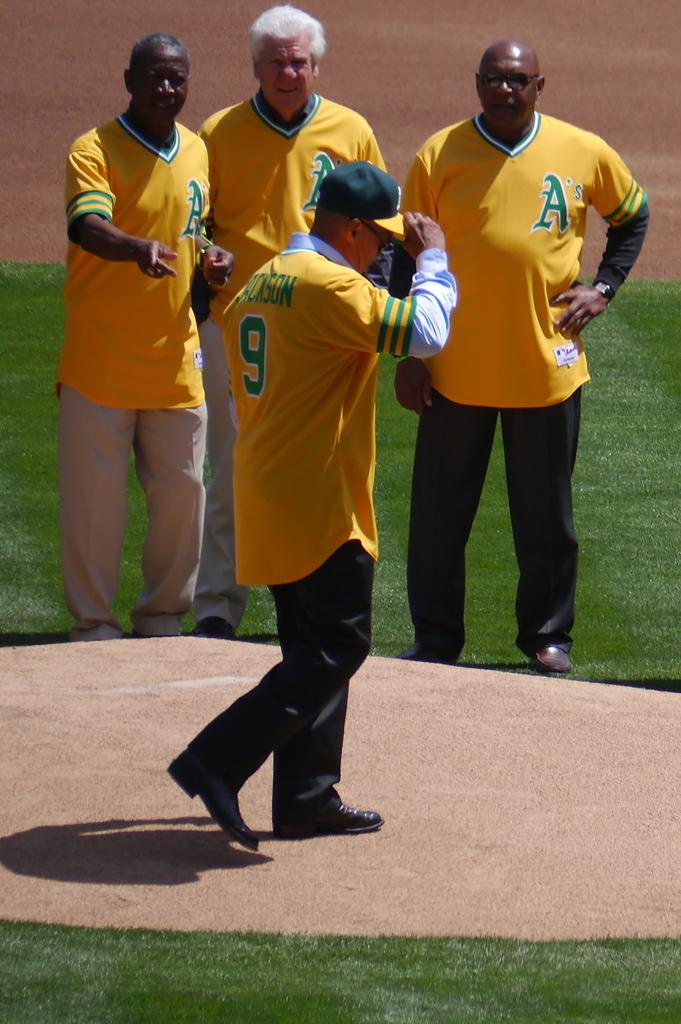<image>
Relay a brief, clear account of the picture shown. An older man named Jackson has a number 9 on his uniform. 